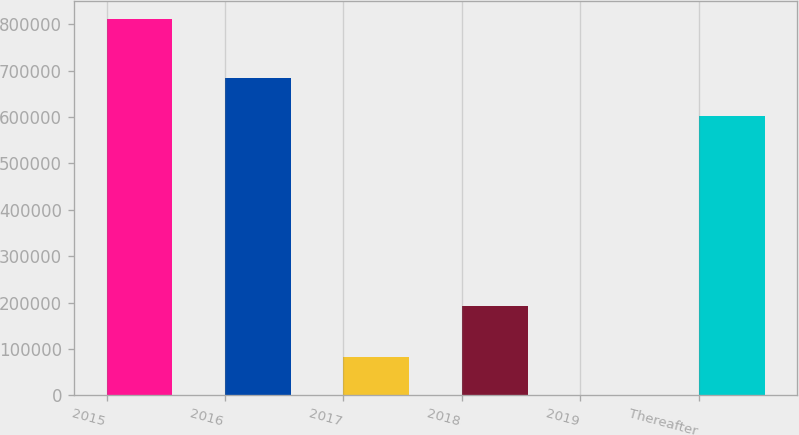Convert chart to OTSL. <chart><loc_0><loc_0><loc_500><loc_500><bar_chart><fcel>2015<fcel>2016<fcel>2017<fcel>2018<fcel>2019<fcel>Thereafter<nl><fcel>810477<fcel>683612<fcel>81755.1<fcel>191792<fcel>786<fcel>602643<nl></chart> 